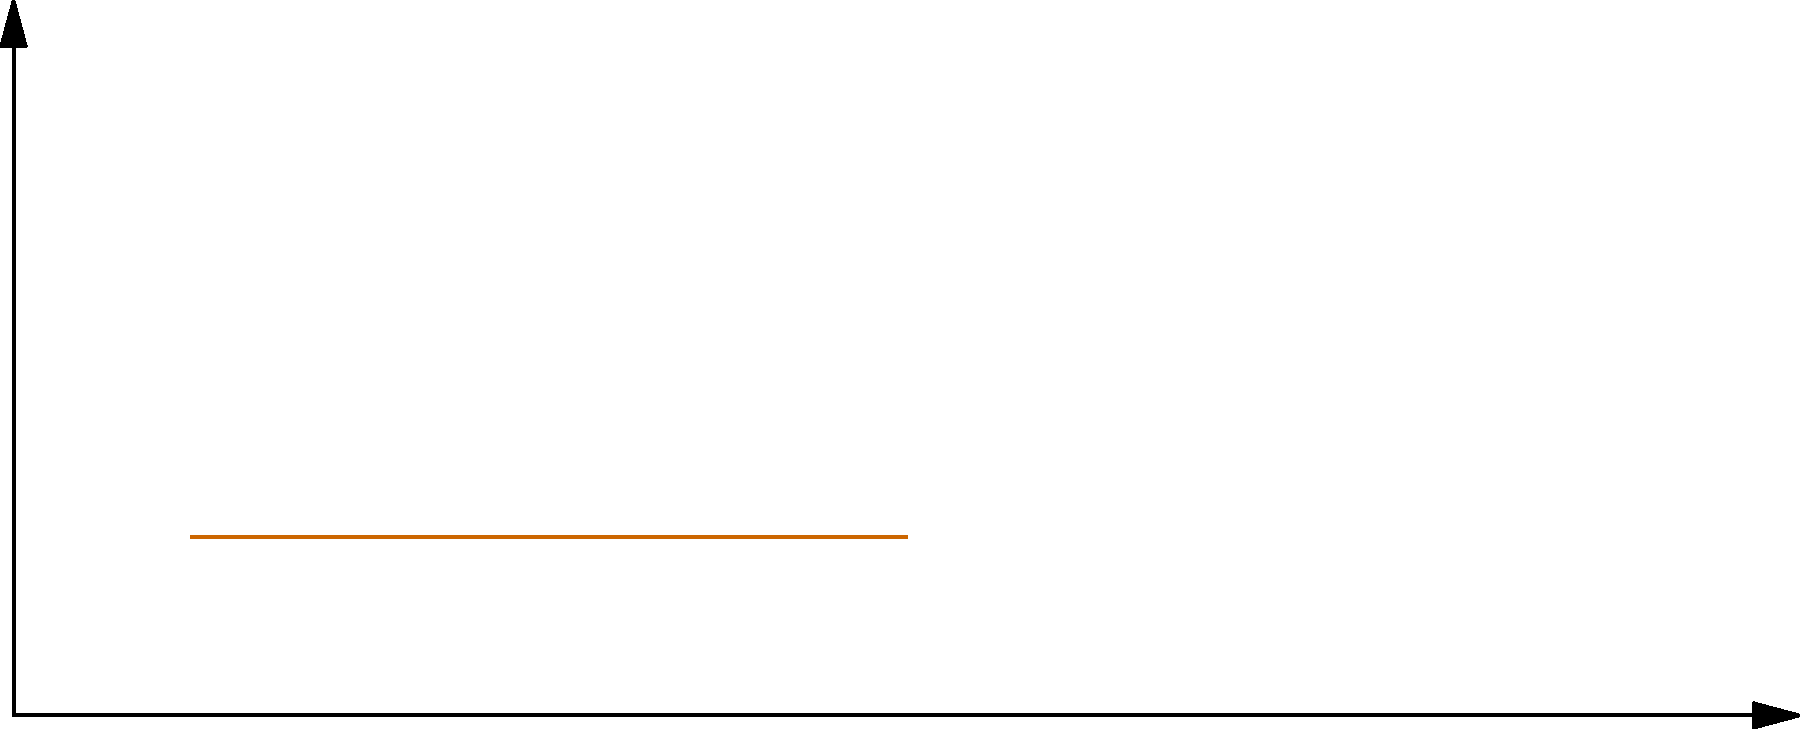In the Git workflow visualization above, which branching strategy is being represented, and how does it compare to other common strategies in terms of release management and feature integration? To answer this question, let's analyze the visualization and compare it to common Git branching strategies:

1. Observe the branches:
   - There are three branches: Master, Develop, and Feature.
   - The Master branch has fewer commits than the Develop branch.
   - The Feature branch splits off from and merges back into the Develop branch.

2. Identify the strategy:
   This visualization represents the Gitflow workflow, a branching model that uses long-running branches and feature branches.

3. Compare with other strategies:
   a) GitHub Flow:
      - Uses only feature branches and master.
      - Simpler, but less structured for releases.
   
   b) GitLab Flow:
      - Similar to GitHub Flow but adds environment branches.
      - More suitable for continuous delivery.
   
   c) Trunk-Based Development:
      - Uses very short-lived feature branches or direct commits to master.
      - Focuses on continuous integration.

4. Analyze Gitflow's characteristics:
   - Master branch: Represents production-ready code.
   - Develop branch: Integration branch for features.
   - Feature branches: Used for developing new features.
   - (Not shown) Release and Hotfix branches for managing releases and urgent fixes.

5. Evaluate Gitflow's strengths:
   - Structured approach to releases.
   - Clear separation of feature development.
   - Supports parallel development of multiple features.

6. Consider Gitflow's challenges:
   - More complex than simpler models.
   - Can lead to longer-lived branches and integration issues.
   - May slow down continuous deployment practices.

In conclusion, the visualization represents the Gitflow branching strategy, which offers a structured approach to release management and feature integration, but at the cost of increased complexity compared to simpler models like GitHub Flow or Trunk-Based Development.
Answer: Gitflow; structured releases and feature isolation, but more complex than GitHub Flow or Trunk-Based Development. 